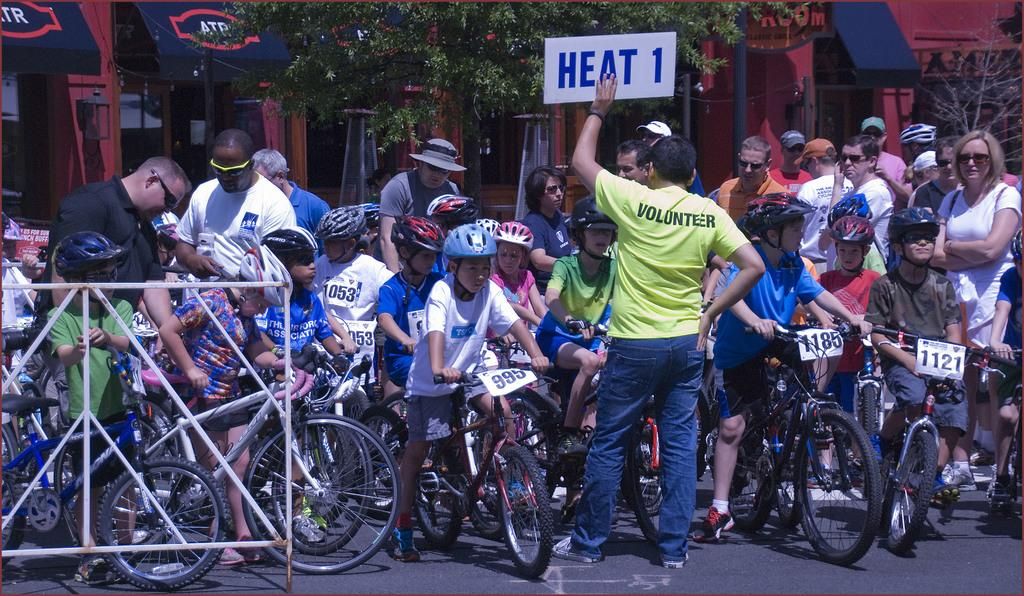What are the children doing in the image? The children are sitting on bicycles in the image. What else can be seen in the image besides the children on bicycles? People are standing on the road in the image. What can be seen in the background of the image? There are buildings, trees, and grills visible in the background of the image. What type of beef is being cooked on the grills in the image? There is no beef or grills visible in the image; only bicycles, people, buildings, trees, and grills are mentioned. 